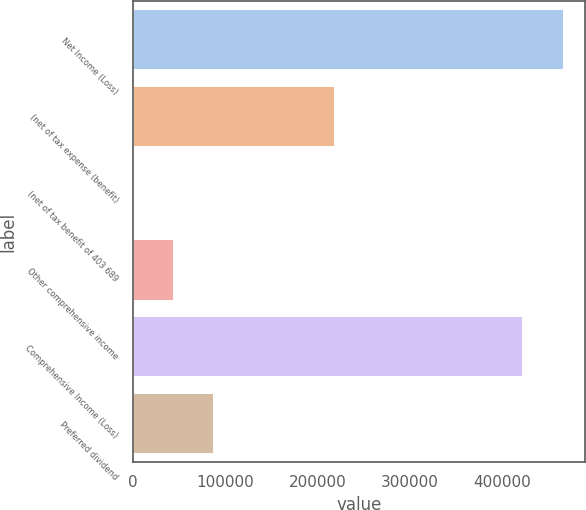Convert chart to OTSL. <chart><loc_0><loc_0><loc_500><loc_500><bar_chart><fcel>Net Income (Loss)<fcel>(net of tax expense (benefit)<fcel>(net of tax benefit of 403 689<fcel>Other comprehensive income<fcel>Comprehensive Income (Loss)<fcel>Preferred dividend<nl><fcel>466656<fcel>218770<fcel>748<fcel>44352.5<fcel>423052<fcel>87957<nl></chart> 